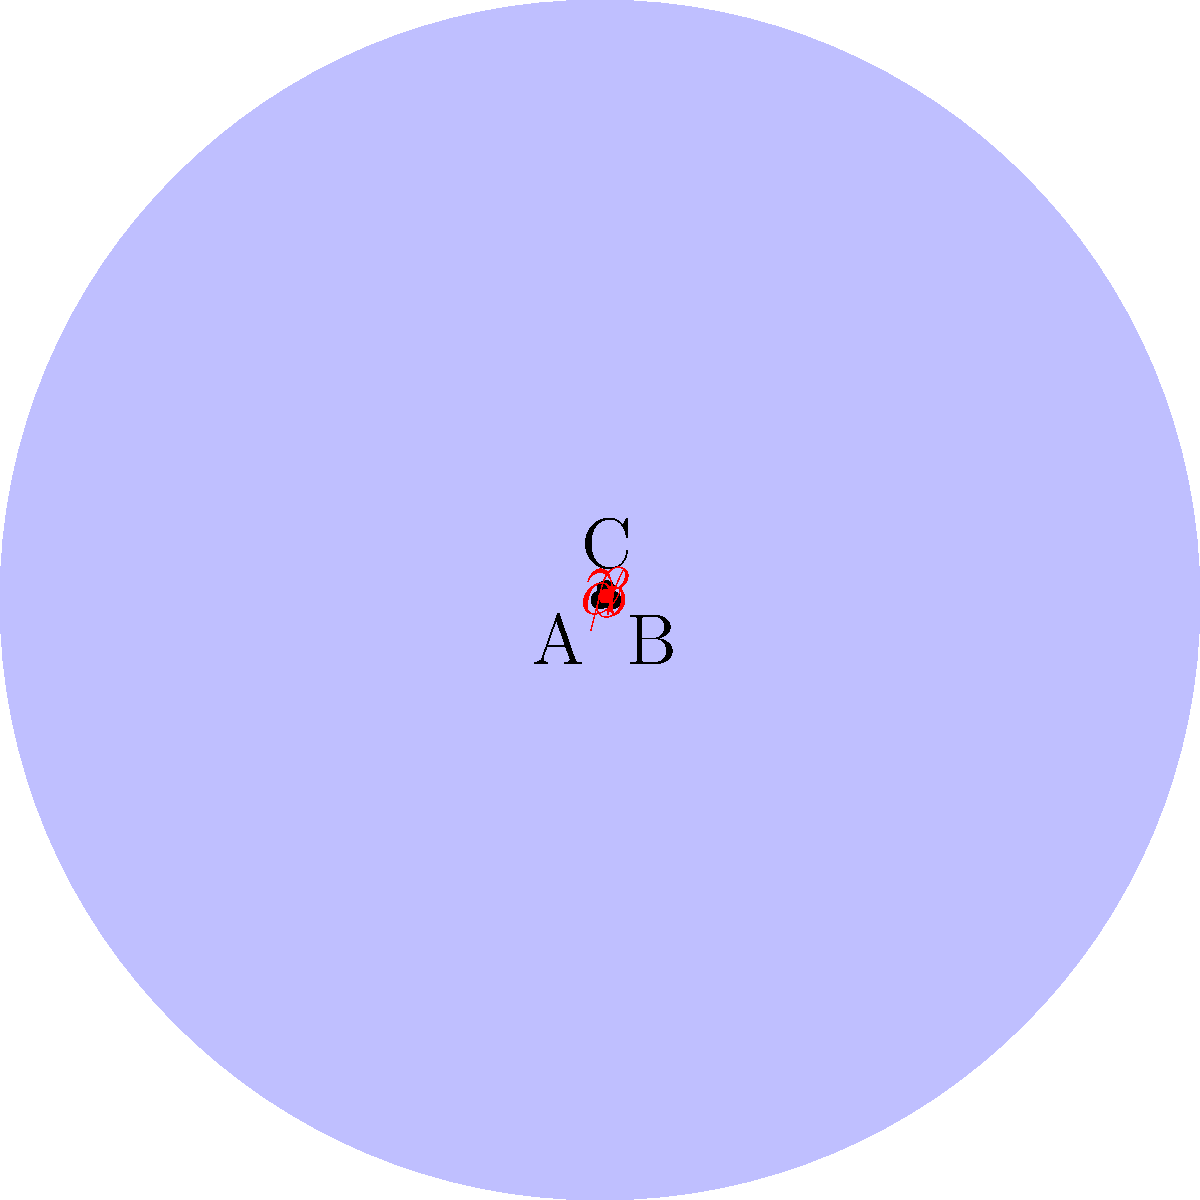In a surreal sleep paralysis scenario, you find yourself trapped within a non-Euclidean triangular space. The angles of this triangle, labeled $\alpha$, $\beta$, and $\gamma$, seem to defy conventional geometry. If the sum of these angles is 270°, which is greater than the Euclidean sum of 180°, what does this imply about the curvature of the space you're experiencing in this dream state? To understand the implications of the angle sum in this non-Euclidean space, let's follow these steps:

1) In Euclidean geometry, the sum of angles in a triangle is always 180°. This is a fundamental property of flat space.

2) The given scenario states that the sum of angles $\alpha + \beta + \gamma = 270°$, which is 90° more than the Euclidean sum.

3) In non-Euclidean geometry, the sum of angles in a triangle can deviate from 180°. This deviation is directly related to the curvature of the space:

   a) If the sum > 180°, the space has positive curvature (like a sphere's surface).
   b) If the sum < 180°, the space has negative curvature (like a saddle shape).

4) In this case, 270° > 180°, indicating positive curvature.

5) Positive curvature in dream space could be interpreted as a closed, finite universe where parallel lines eventually intersect.

6) This curved space in the sleep paralysis scenario might represent the mind's attempt to reconcile the dream state with physical reality, creating a surreal, enclosed environment.

Therefore, the 270° sum implies that the dreamer is experiencing a positively curved, non-Euclidean space in this surreal sleep paralysis scenario.
Answer: Positive curvature 